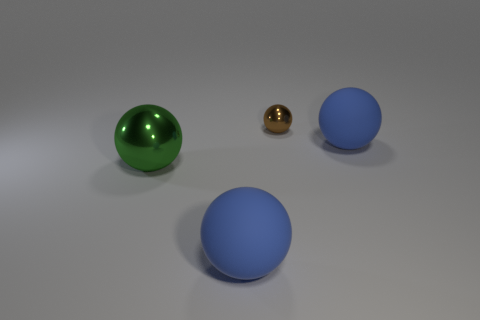Subtract 1 balls. How many balls are left? 3 Subtract all yellow balls. Subtract all green cylinders. How many balls are left? 4 Add 4 blue spheres. How many objects exist? 8 Subtract all brown metal balls. Subtract all large green things. How many objects are left? 2 Add 4 blue objects. How many blue objects are left? 6 Add 3 large green metal objects. How many large green metal objects exist? 4 Subtract 0 brown blocks. How many objects are left? 4 